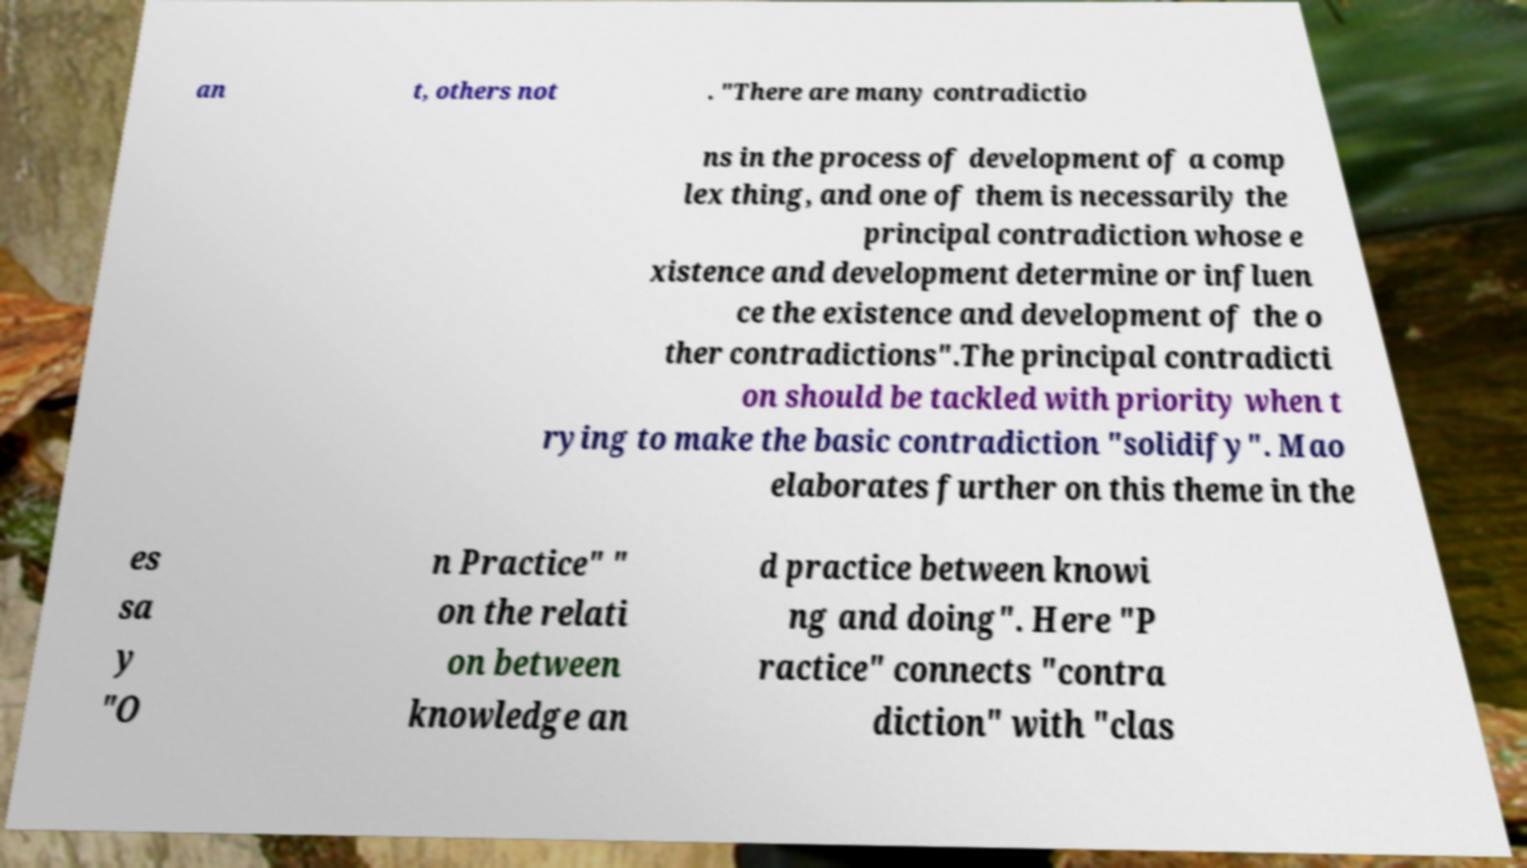Can you accurately transcribe the text from the provided image for me? an t, others not . "There are many contradictio ns in the process of development of a comp lex thing, and one of them is necessarily the principal contradiction whose e xistence and development determine or influen ce the existence and development of the o ther contradictions".The principal contradicti on should be tackled with priority when t rying to make the basic contradiction "solidify". Mao elaborates further on this theme in the es sa y "O n Practice" " on the relati on between knowledge an d practice between knowi ng and doing". Here "P ractice" connects "contra diction" with "clas 